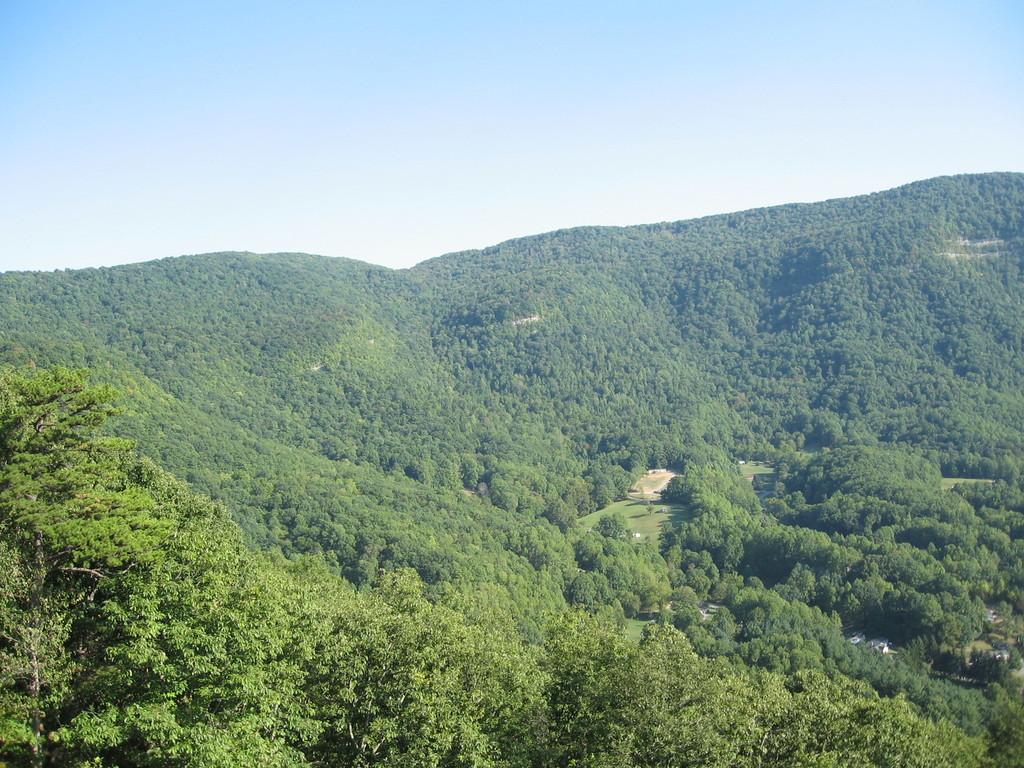In one or two sentences, can you explain what this image depicts? In this image we can see trees, houses, grass, mountains and clouds in the sky. 